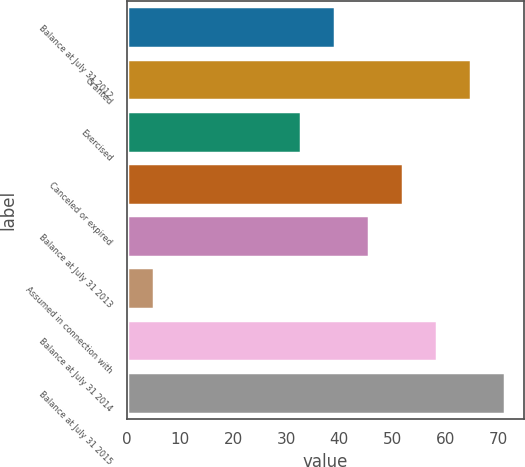Convert chart. <chart><loc_0><loc_0><loc_500><loc_500><bar_chart><fcel>Balance at July 31 2012<fcel>Granted<fcel>Exercised<fcel>Canceled or expired<fcel>Balance at July 31 2013<fcel>Assumed in connection with<fcel>Balance at July 31 2014<fcel>Balance at July 31 2015<nl><fcel>39.19<fcel>64.79<fcel>32.79<fcel>51.99<fcel>45.59<fcel>5.16<fcel>58.39<fcel>71.19<nl></chart> 